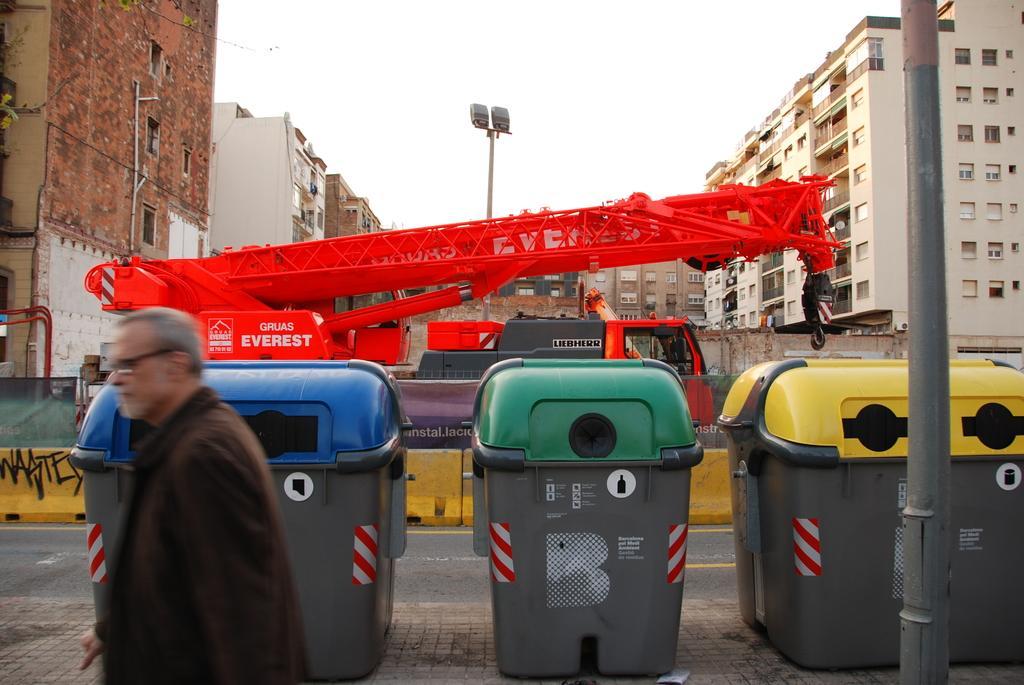Please provide a concise description of this image. In this image we can see a person wearing the glasses on the left. We can also see the bins, pole, light pole and also a crane machine. We can also see the barrier, road and also the path. In the background we can see the buildings and also the sky. 